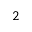Convert formula to latex. <formula><loc_0><loc_0><loc_500><loc_500>^ { 2 }</formula> 